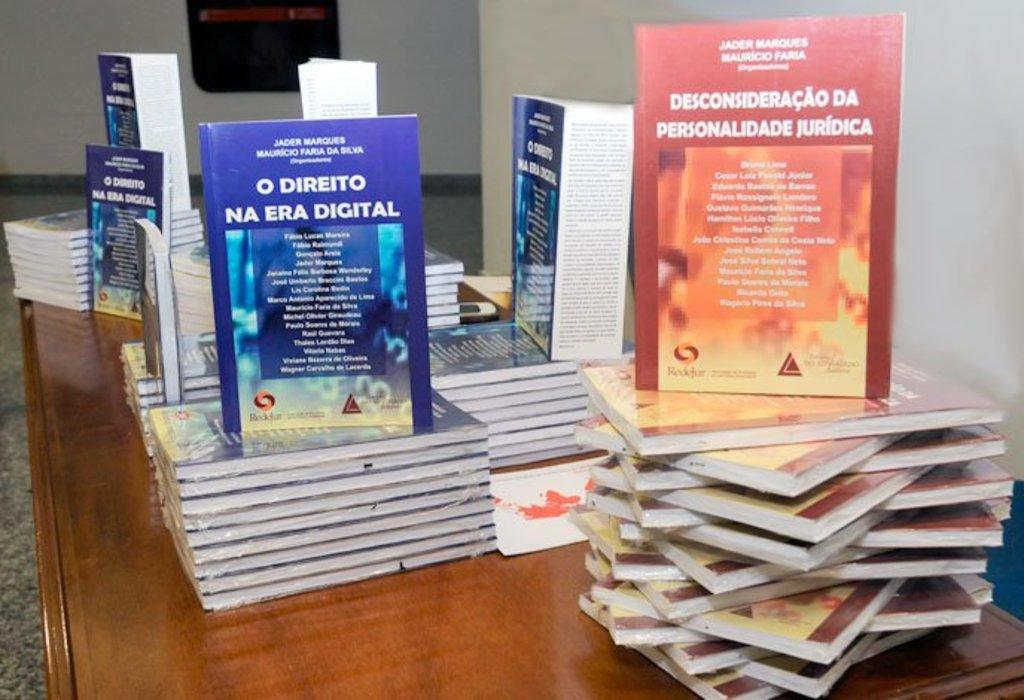Provide a one-sentence caption for the provided image. A table containing a few piles of books including the title O Direito Na Era Digital. 